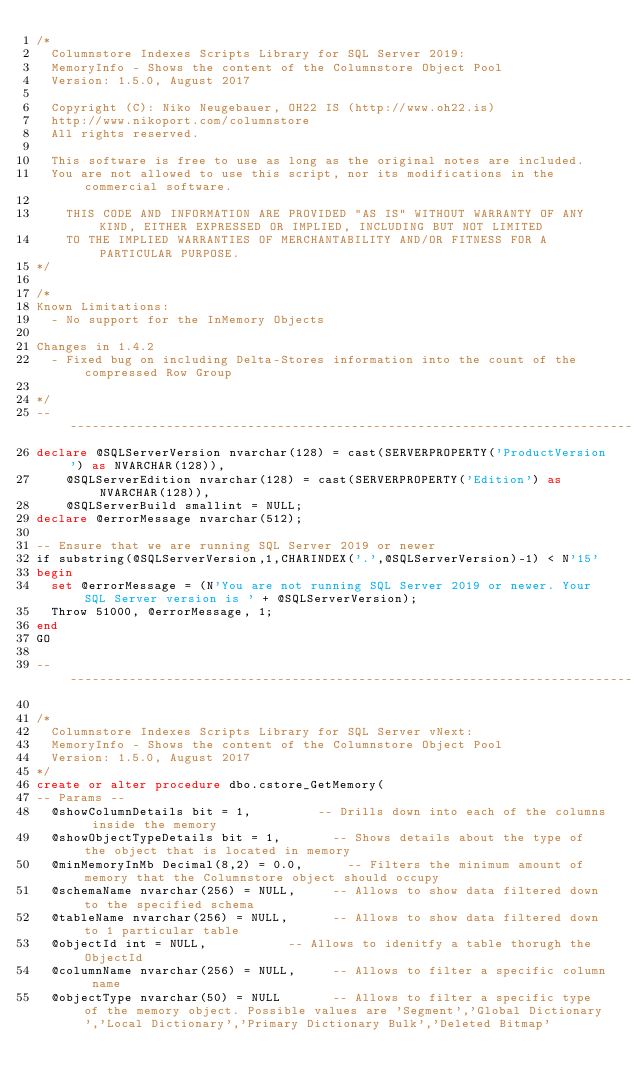Convert code to text. <code><loc_0><loc_0><loc_500><loc_500><_SQL_>/*
	Columnstore Indexes Scripts Library for SQL Server 2019: 
	MemoryInfo - Shows the content of the Columnstore Object Pool
	Version: 1.5.0, August 2017

	Copyright (C): Niko Neugebauer, OH22 IS (http://www.oh22.is)
	http://www.nikoport.com/columnstore	
	All rights reserved.

	This software is free to use as long as the original notes are included.
	You are not allowed to use this script, nor its modifications in the commercial software.

    THIS CODE AND INFORMATION ARE PROVIDED "AS IS" WITHOUT WARRANTY OF ANY KIND, EITHER EXPRESSED OR IMPLIED, INCLUDING BUT NOT LIMITED 
    TO THE IMPLIED WARRANTIES OF MERCHANTABILITY AND/OR FITNESS FOR A PARTICULAR PURPOSE. 
*/

/*
Known Limitations:
	- No support for the InMemory Objects

Changes in 1.4.2
	- Fixed bug on including Delta-Stores information into the count of the compressed Row Group

*/
--------------------------------------------------------------------------------------------------------------------
declare @SQLServerVersion nvarchar(128) = cast(SERVERPROPERTY('ProductVersion') as NVARCHAR(128)), 
		@SQLServerEdition nvarchar(128) = cast(SERVERPROPERTY('Edition') as NVARCHAR(128)),
		@SQLServerBuild smallint = NULL;
declare @errorMessage nvarchar(512);

-- Ensure that we are running SQL Server 2019 or newer
if substring(@SQLServerVersion,1,CHARINDEX('.',@SQLServerVersion)-1) < N'15'
begin
	set @errorMessage = (N'You are not running SQL Server 2019 or newer. Your SQL Server version is ' + @SQLServerVersion);
	Throw 51000, @errorMessage, 1;
end
GO

--------------------------------------------------------------------------------------------------------------------

/*
	Columnstore Indexes Scripts Library for SQL Server vNext: 
	MemoryInfo - Shows the content of the Columnstore Object Pool
	Version: 1.5.0, August 2017
*/
create or alter procedure dbo.cstore_GetMemory(
-- Params --
	@showColumnDetails bit = 1,					-- Drills down into each of the columns inside the memory
	@showObjectTypeDetails bit = 1,				-- Shows details about the type of the object that is located in memory
	@minMemoryInMb Decimal(8,2) = 0.0,			-- Filters the minimum amount of memory that the Columnstore object should occupy
	@schemaName nvarchar(256) = NULL,			-- Allows to show data filtered down to the specified schema
	@tableName nvarchar(256) = NULL,			-- Allows to show data filtered down to 1 particular table
	@objectId int = NULL,						-- Allows to idenitfy a table thorugh the ObjectId
	@columnName nvarchar(256) = NULL,			-- Allows to filter a specific column name
	@objectType nvarchar(50) = NULL				-- Allows to filter a specific type of the memory object. Possible values are 'Segment','Global Dictionary','Local Dictionary','Primary Dictionary Bulk','Deleted Bitmap'</code> 